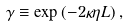Convert formula to latex. <formula><loc_0><loc_0><loc_500><loc_500>\gamma \equiv \exp { ( - 2 \kappa \eta L ) } \, ,</formula> 